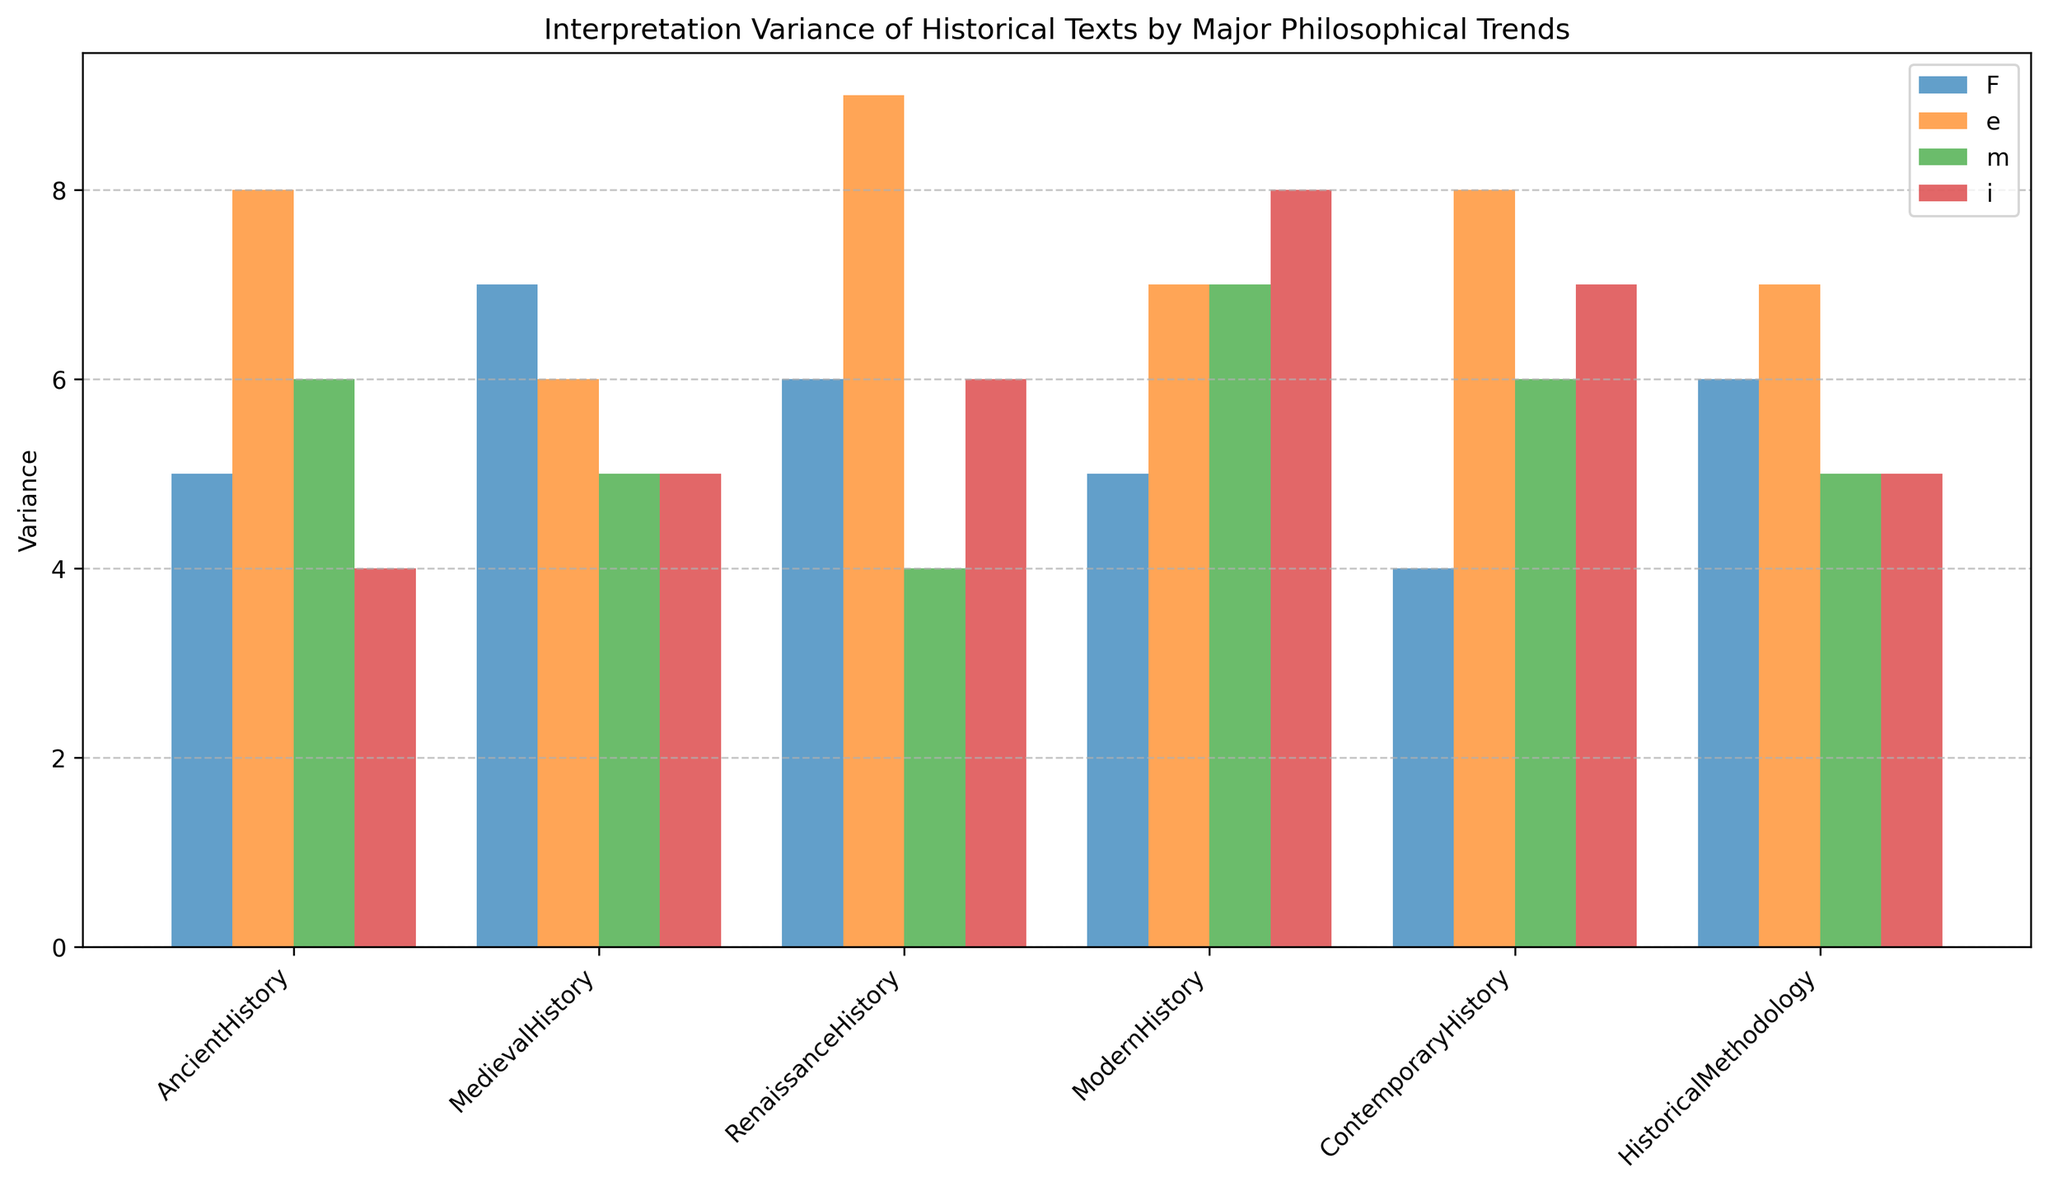Which major has the highest interpretation variance in Positivism? By looking at the height of the bars labeled for Positivism in the figure, we see that Medieval History has the tallest bar, indicating the highest interpretation variance.
Answer: Medieval History Which major shows a higher interpretation variance in Feminism compared to Positivism? To answer this, compare the heights of the bars representing Feminism and Positivism for each major. We see that Modern History, Contemporary History, and Renaissance History have taller bars for Feminism than for Positivism.
Answer: Modern History, Contemporary History, Renaissance History What is the average interpretation variance for Renaissance History across all philosophical trends? Sum the interpretation variances for Renaissance History: 6 (Positivism) + 9 (Postmodernism) + 4 (Marxism) + 6 (Feminism) = 25, then divide by the number of trends (4). 25/4 = 6.25
Answer: 6.25 How does the variance in Postmodernism for Modern History compare to that of Medieval History? Compare the heights of the bars for Postmodernism. The bar for Modern History is at 7, while the bar for Medieval History is at 6, indicating Modern History has a higher variance in Postmodernism.
Answer: Modern History has higher variance Which philosophical trend shows the most consistent (least variable) interpretation variance across all historical majors? Visually check the heights of the bars across all majors and observe which trend shows the least fluctuation in height. The bars for Marxism appear the most consistent.
Answer: Marxism Which historical major has the greatest disparity in interpretation variance between Positivism and Feminism? Calculate the difference in heights for Positivism and Feminism for each major. Medieval History and Contemporary History both show a difference of 3 (but opposite biases: Medieval higher in Positivism, Contemporary higher in Feminism).
Answer: Medieval History & Contemporary History (equal disparity) Which major consistently has lower variance across all philosophical trends? Look for the major with the generally shortest bars across multiple trends. Ancient History appears to have consistently lower bars.
Answer: Ancient History What is the total interpretation variance for Historical Methodology across all trends? Sum the variances for Historical Methodology: 6 (Positivism) + 7 (Postmodernism) + 5 (Marxism) + 5 (Feminism) = 23.
Answer: 23 